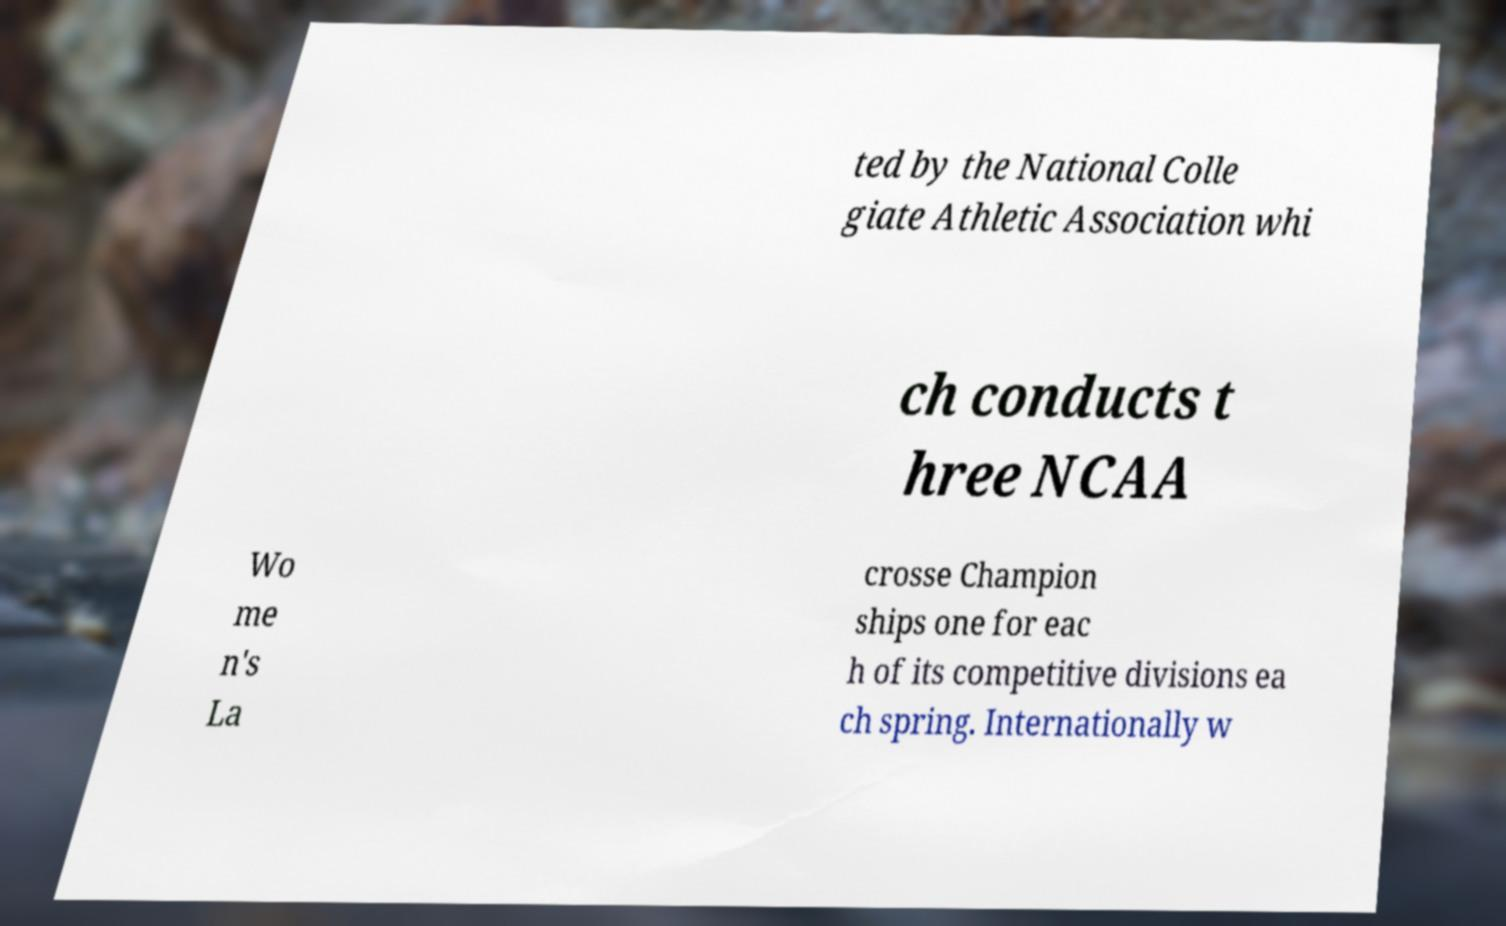Please identify and transcribe the text found in this image. ted by the National Colle giate Athletic Association whi ch conducts t hree NCAA Wo me n's La crosse Champion ships one for eac h of its competitive divisions ea ch spring. Internationally w 